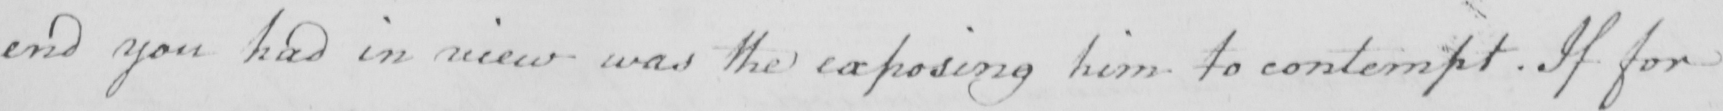Please transcribe the handwritten text in this image. end you had in mind was the exposing him to contempt . If for 